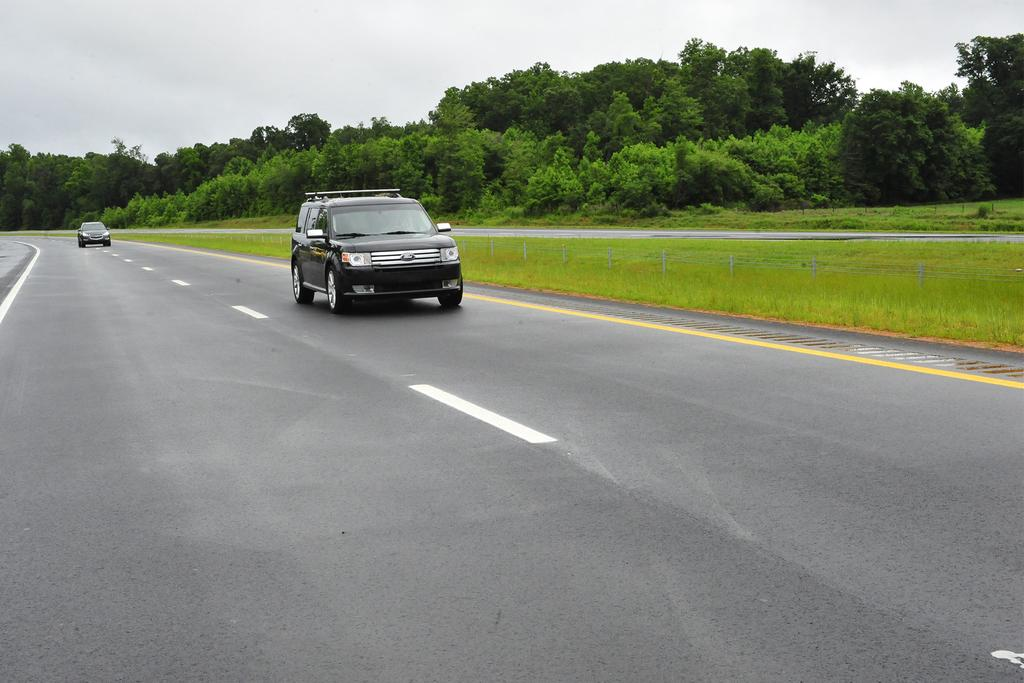How many vehicles can be seen on the road in the image? There are two vehicles on the road in the image. What type of natural elements are present in the image? There are trees, plants, and grass in the image. What part of the natural environment is visible in the image? The sky is visible in the image. What type of flame can be seen coming from the guide's torch in the image? There is no guide or torch present in the image; it features two vehicles on the road and natural elements. 